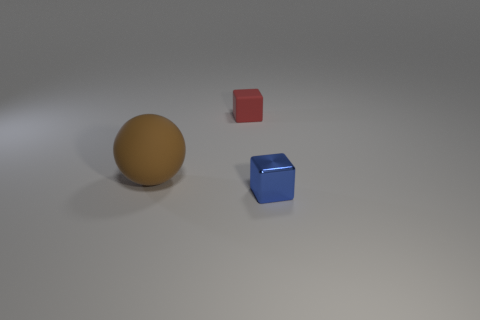There is a small thing in front of the red rubber thing; is it the same shape as the rubber thing to the right of the large brown thing? Yes, the small red object in front of the large brown sphere is a cube, and it shares the same shape as the blue cube positioned to the right of the sphere. Both objects are cubes, featuring identical geometry with six square faces, edges of equal length, and right-angle corners. 